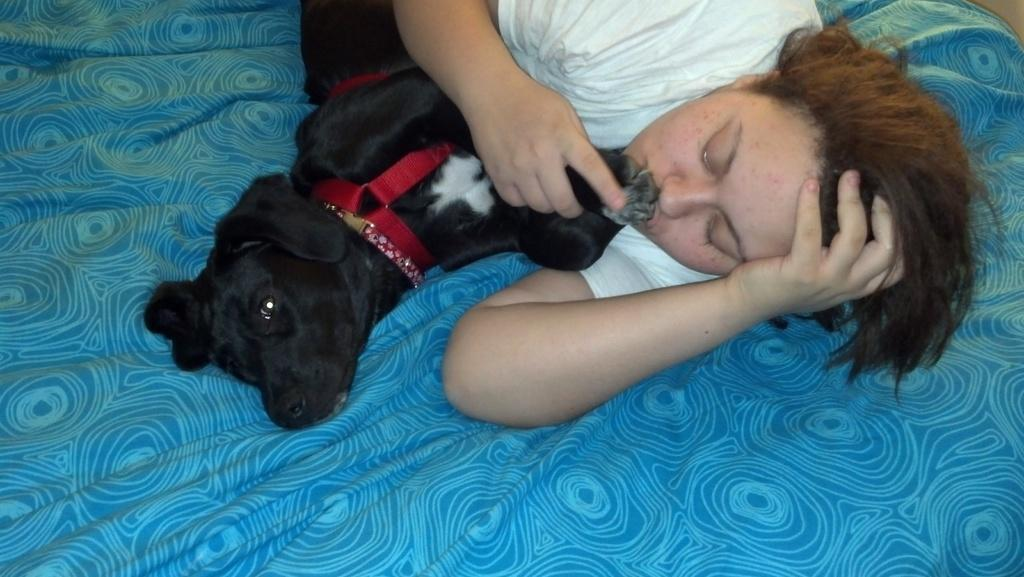What is the person in the image doing? There is a person lying in the image. What is the person holding in the image? The person is holding a dog. Can you describe the dog in the image? The dog is black and lying beside the person. How many stitches are visible on the dog's collar in the image? There is no collar visible on the dog in the image, so it is not possible to determine the number of stitches. 